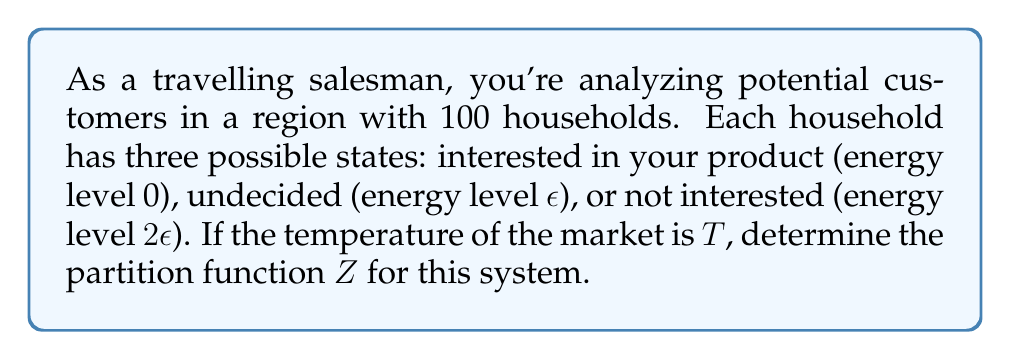Provide a solution to this math problem. To solve this problem, we'll follow these steps:

1) Recall the general form of the partition function:
   $$Z = \sum_i g_i e^{-\beta E_i}$$
   where $g_i$ is the degeneracy of state $i$, $\beta = \frac{1}{k_B T}$, and $E_i$ is the energy of state $i$.

2) In this case, we have three energy levels:
   $E_1 = 0$, $E_2 = \epsilon$, $E_3 = 2\epsilon$

3) The degeneracy for each state is 100, as each of the 100 households can be in any of these states.

4) Let's substitute these into our partition function:
   $$Z = 100e^{-\beta \cdot 0} + 100e^{-\beta \epsilon} + 100e^{-\beta \cdot 2\epsilon}$$

5) Simplify:
   $$Z = 100(1 + e^{-\beta \epsilon} + e^{-2\beta \epsilon})$$

6) Recall that $\beta = \frac{1}{k_B T}$. Let's substitute this:
   $$Z = 100(1 + e^{-\epsilon/(k_B T)} + e^{-2\epsilon/(k_B T)})$$

This is our final form of the partition function.
Answer: $Z = 100(1 + e^{-\epsilon/(k_B T)} + e^{-2\epsilon/(k_B T)})$ 